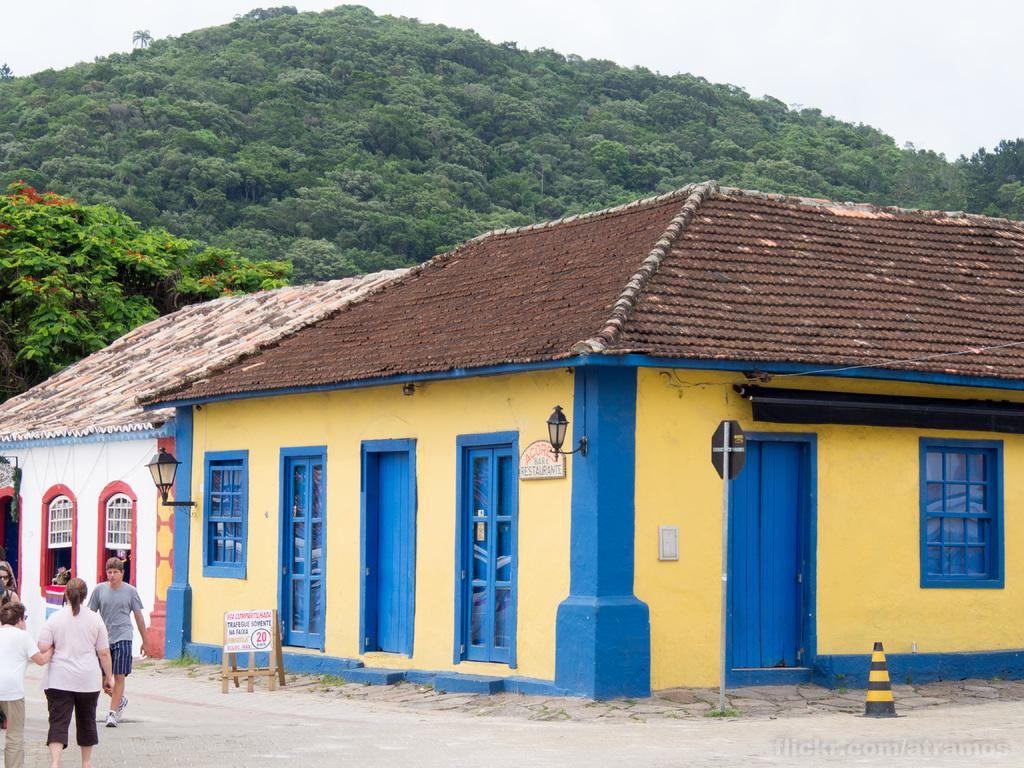What type of objects can be seen in the image? There are seeds, trees, a board, and a traffic cone visible in the image. Where are the people located in the image? The people are on the left side of the image. What can be seen in the background of the image? There are hills and the sky visible in the background of the image. What might the board be used for in the image? The board could be used for writing, displaying information, or as a surface for other activities. Can you tell me how many a story about the aunt who lives on the coast and is sitting on the sofa in the image? There is no aunt, coast, or sofa present in the image. 